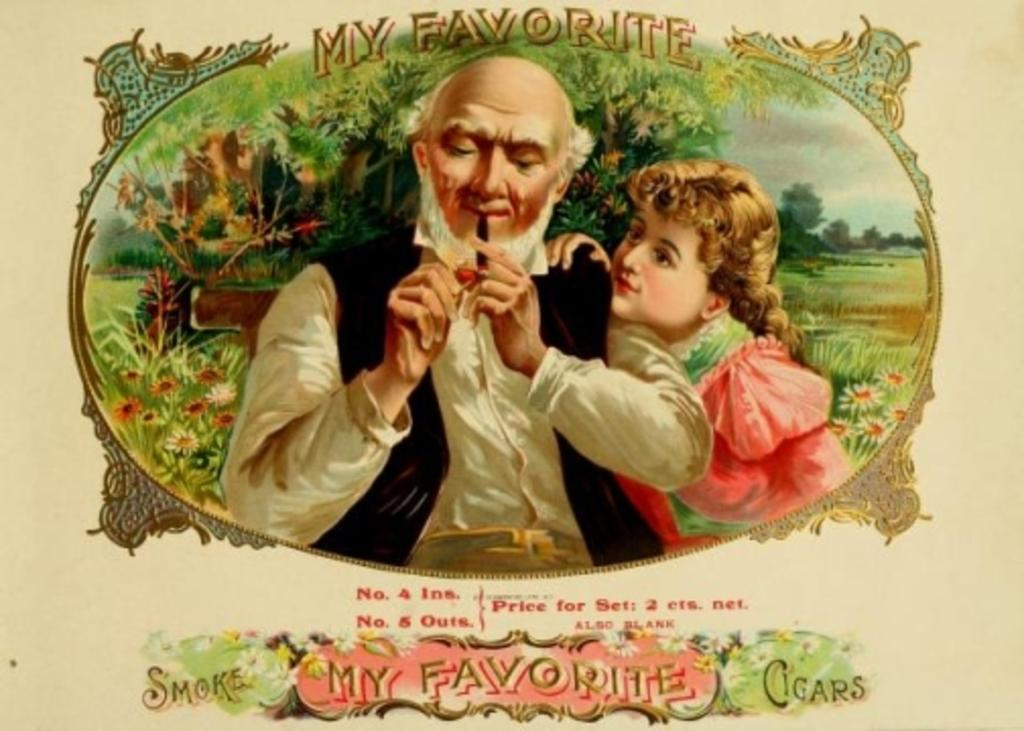<image>
Present a compact description of the photo's key features. A vintage ad for My Favorite Cigars showing an old man. 